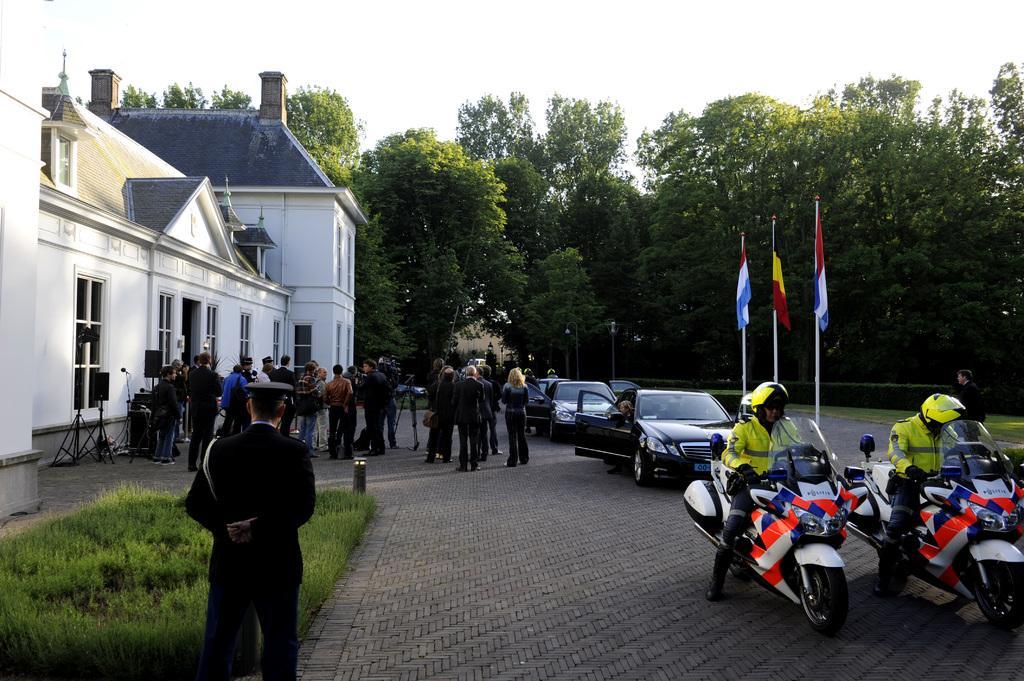Can you describe this image briefly? Here we can see two motorcycles and three cars on the road. There are a group of people who are standing. Here we can see a house, trees and flags. 